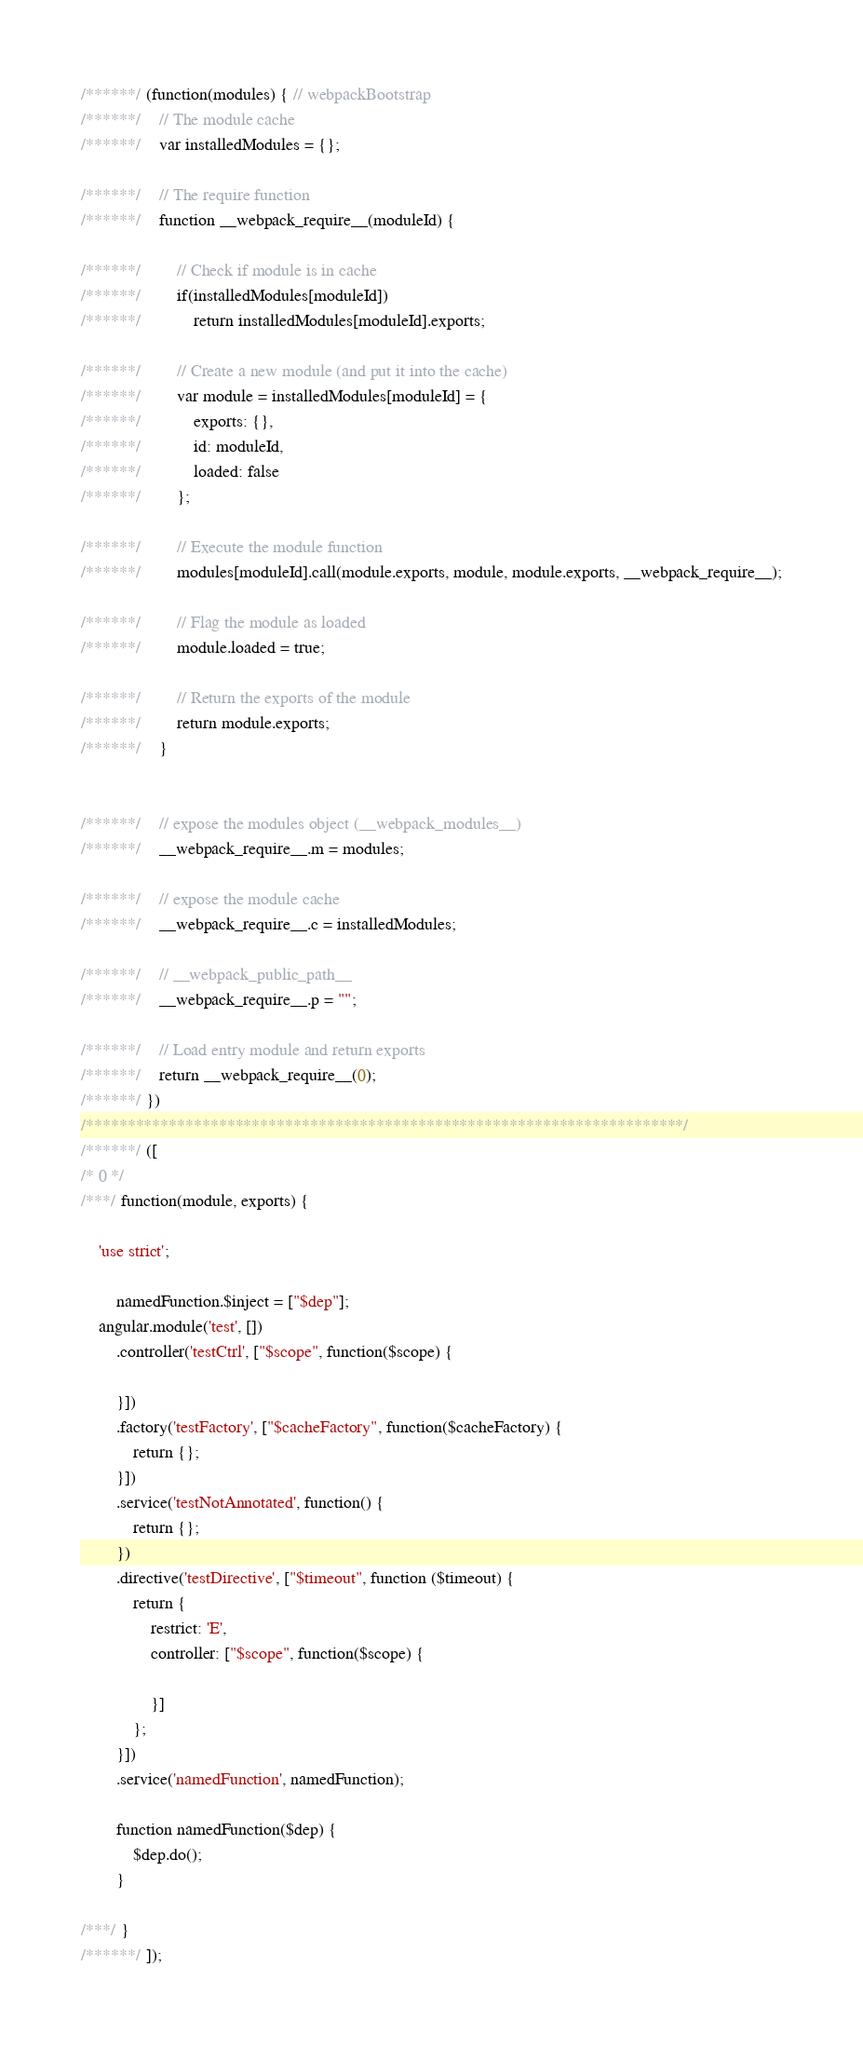<code> <loc_0><loc_0><loc_500><loc_500><_JavaScript_>/******/ (function(modules) { // webpackBootstrap
/******/ 	// The module cache
/******/ 	var installedModules = {};

/******/ 	// The require function
/******/ 	function __webpack_require__(moduleId) {

/******/ 		// Check if module is in cache
/******/ 		if(installedModules[moduleId])
/******/ 			return installedModules[moduleId].exports;

/******/ 		// Create a new module (and put it into the cache)
/******/ 		var module = installedModules[moduleId] = {
/******/ 			exports: {},
/******/ 			id: moduleId,
/******/ 			loaded: false
/******/ 		};

/******/ 		// Execute the module function
/******/ 		modules[moduleId].call(module.exports, module, module.exports, __webpack_require__);

/******/ 		// Flag the module as loaded
/******/ 		module.loaded = true;

/******/ 		// Return the exports of the module
/******/ 		return module.exports;
/******/ 	}


/******/ 	// expose the modules object (__webpack_modules__)
/******/ 	__webpack_require__.m = modules;

/******/ 	// expose the module cache
/******/ 	__webpack_require__.c = installedModules;

/******/ 	// __webpack_public_path__
/******/ 	__webpack_require__.p = "";

/******/ 	// Load entry module and return exports
/******/ 	return __webpack_require__(0);
/******/ })
/************************************************************************/
/******/ ([
/* 0 */
/***/ function(module, exports) {

	'use strict';

		namedFunction.$inject = ["$dep"];
	angular.module('test', [])
		.controller('testCtrl', ["$scope", function($scope) {

		}])
		.factory('testFactory', ["$cacheFactory", function($cacheFactory) {
			return {};
		}])
		.service('testNotAnnotated', function() {
			return {};
		})
		.directive('testDirective', ["$timeout", function ($timeout) {
			return {
				restrict: 'E',
				controller: ["$scope", function($scope) {

				}]
			};
		}])
		.service('namedFunction', namedFunction);

		function namedFunction($dep) {
			$dep.do();
		}

/***/ }
/******/ ]);</code> 